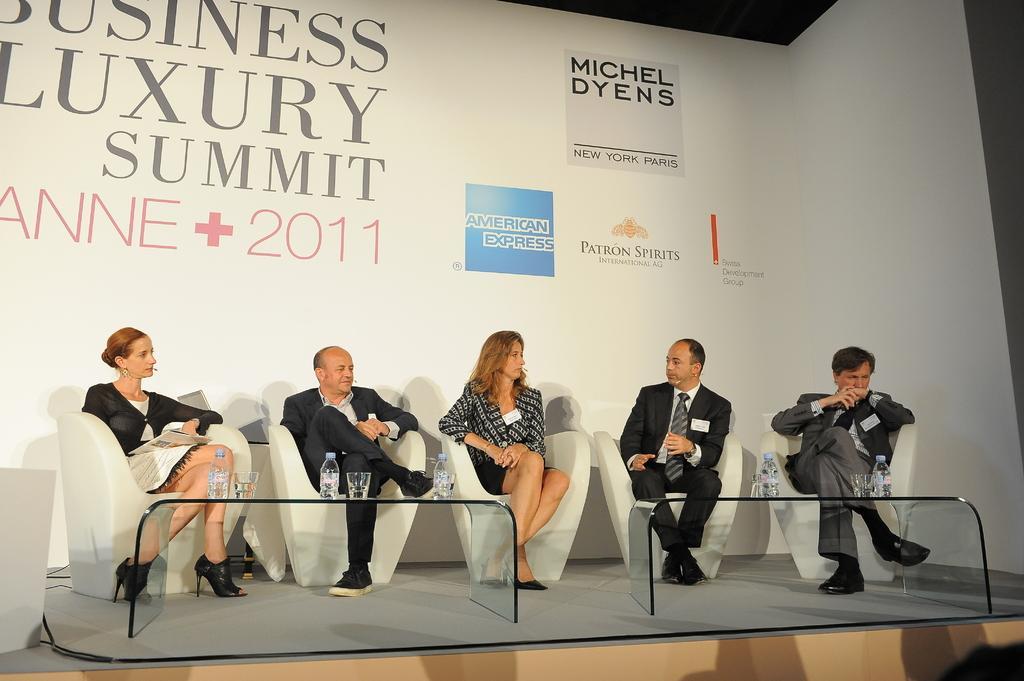Can you describe this image briefly? Here in this picture we can see a group of people sitting on chairs with tables in front of them having bottles and glasses on it over there and behind them we can see a banner present over there. 